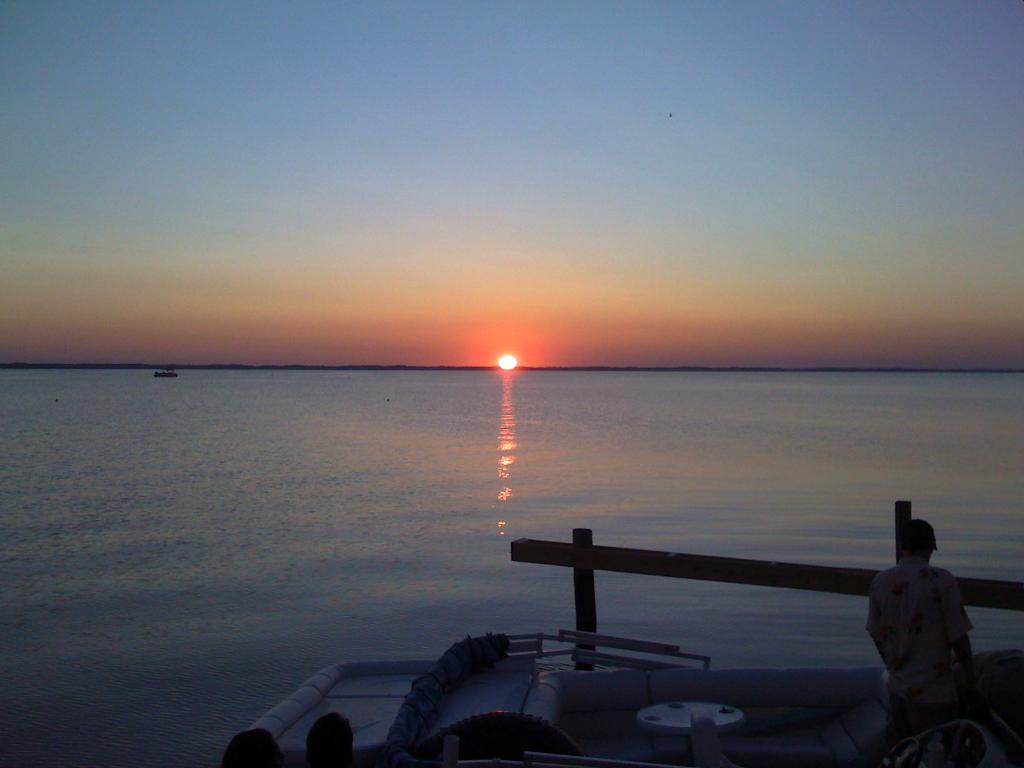In one or two sentences, can you explain what this image depicts? In this image, we can see the sea. Here a person is standing. At the bottom, we can see human heads, some objects, poles. Top of the image, there is a sky. 